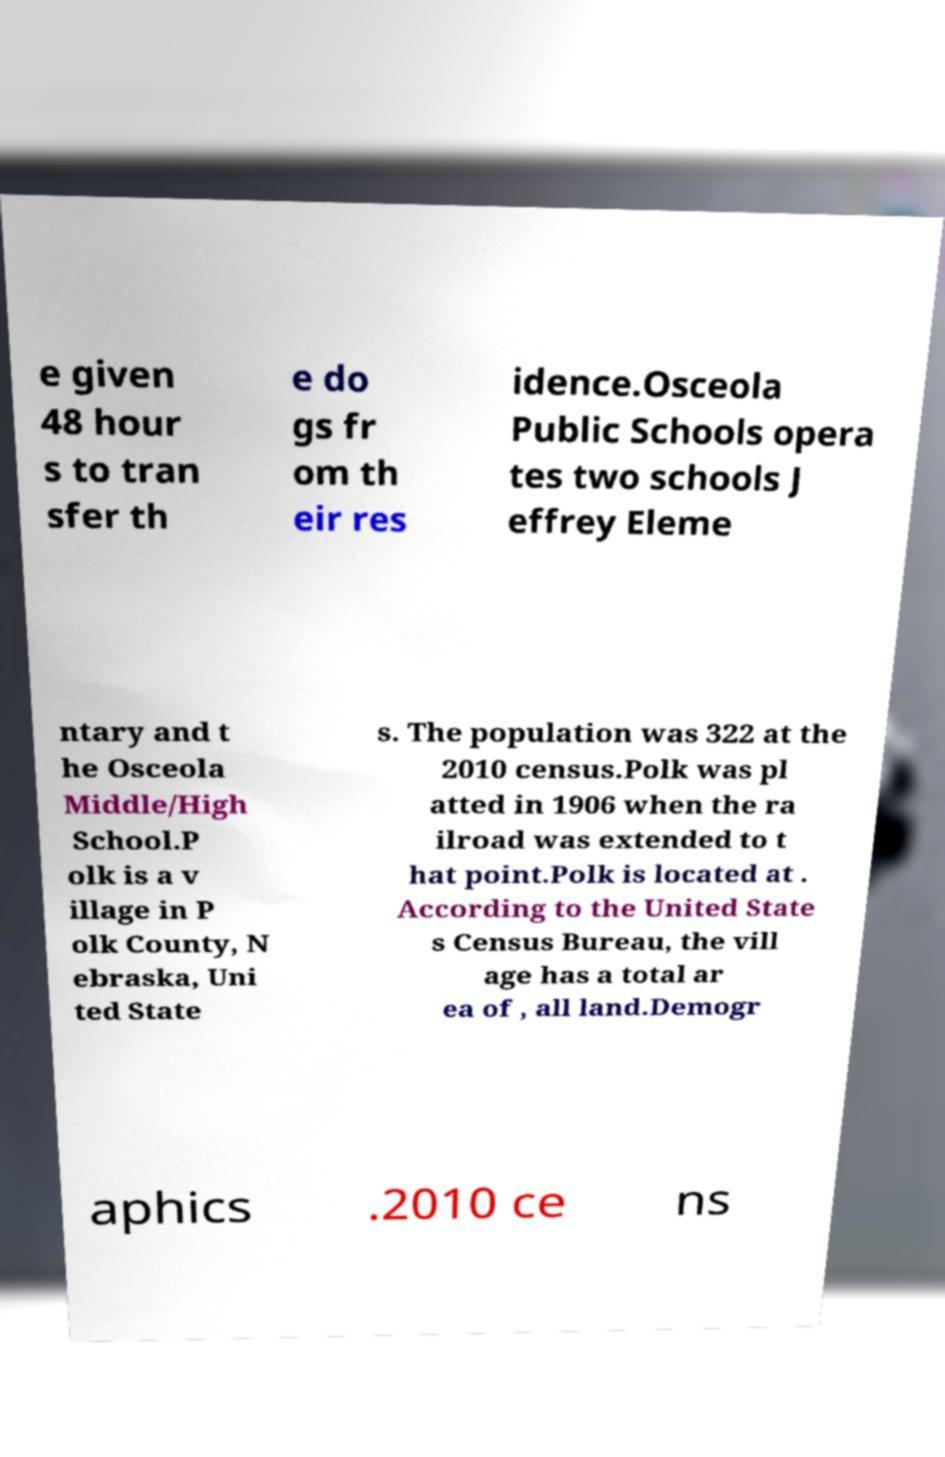Could you extract and type out the text from this image? e given 48 hour s to tran sfer th e do gs fr om th eir res idence.Osceola Public Schools opera tes two schools J effrey Eleme ntary and t he Osceola Middle/High School.P olk is a v illage in P olk County, N ebraska, Uni ted State s. The population was 322 at the 2010 census.Polk was pl atted in 1906 when the ra ilroad was extended to t hat point.Polk is located at . According to the United State s Census Bureau, the vill age has a total ar ea of , all land.Demogr aphics .2010 ce ns 